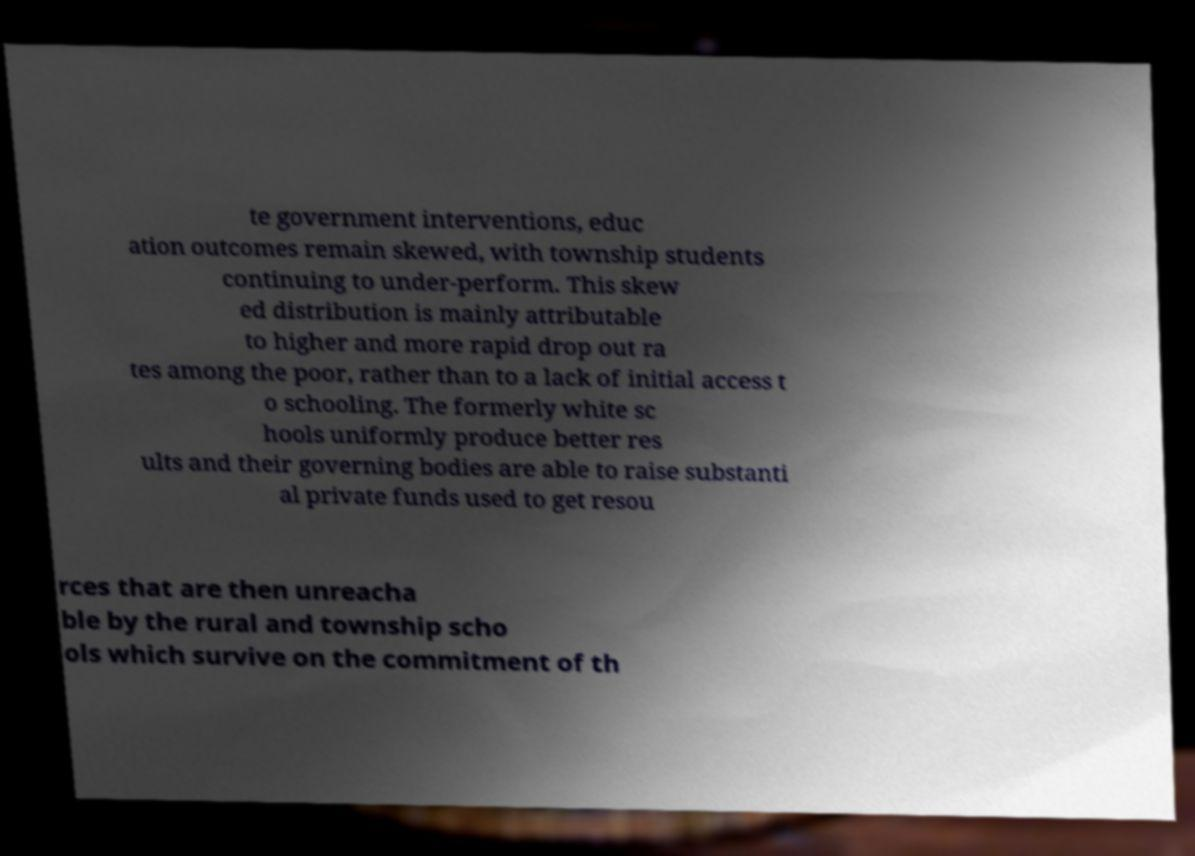Please read and relay the text visible in this image. What does it say? te government interventions, educ ation outcomes remain skewed, with township students continuing to under-perform. This skew ed distribution is mainly attributable to higher and more rapid drop out ra tes among the poor, rather than to a lack of initial access t o schooling. The formerly white sc hools uniformly produce better res ults and their governing bodies are able to raise substanti al private funds used to get resou rces that are then unreacha ble by the rural and township scho ols which survive on the commitment of th 